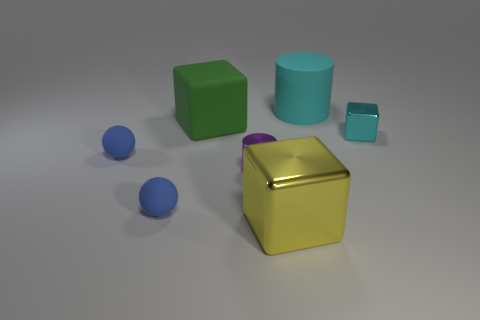There is a large green block that is in front of the cyan object behind the big green matte cube; what is it made of?
Offer a terse response. Rubber. Is the material of the yellow object the same as the big cube to the left of the shiny cylinder?
Offer a very short reply. No. What is the material of the object that is both behind the small cyan cube and to the left of the metallic cylinder?
Your answer should be compact. Rubber. What is the color of the big cube in front of the metallic block that is right of the big cyan cylinder?
Provide a short and direct response. Yellow. What is the block behind the small cyan metal cube made of?
Your answer should be very brief. Rubber. Is the number of tiny blue matte balls less than the number of large purple metal objects?
Provide a succinct answer. No. Is the shape of the large cyan matte object the same as the small metallic thing that is to the right of the large yellow shiny object?
Offer a terse response. No. The object that is to the right of the green cube and left of the big yellow object has what shape?
Make the answer very short. Cylinder. Are there the same number of cubes that are to the right of the matte cylinder and small blue spheres behind the big yellow shiny object?
Give a very brief answer. No. Do the cyan thing that is in front of the large cyan object and the big yellow shiny thing have the same shape?
Offer a terse response. Yes. 